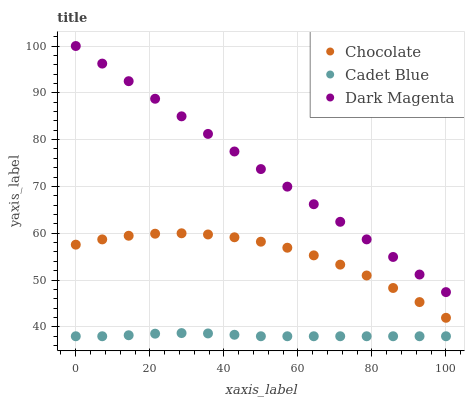Does Cadet Blue have the minimum area under the curve?
Answer yes or no. Yes. Does Dark Magenta have the maximum area under the curve?
Answer yes or no. Yes. Does Chocolate have the minimum area under the curve?
Answer yes or no. No. Does Chocolate have the maximum area under the curve?
Answer yes or no. No. Is Dark Magenta the smoothest?
Answer yes or no. Yes. Is Chocolate the roughest?
Answer yes or no. Yes. Is Chocolate the smoothest?
Answer yes or no. No. Is Dark Magenta the roughest?
Answer yes or no. No. Does Cadet Blue have the lowest value?
Answer yes or no. Yes. Does Chocolate have the lowest value?
Answer yes or no. No. Does Dark Magenta have the highest value?
Answer yes or no. Yes. Does Chocolate have the highest value?
Answer yes or no. No. Is Cadet Blue less than Chocolate?
Answer yes or no. Yes. Is Dark Magenta greater than Chocolate?
Answer yes or no. Yes. Does Cadet Blue intersect Chocolate?
Answer yes or no. No. 